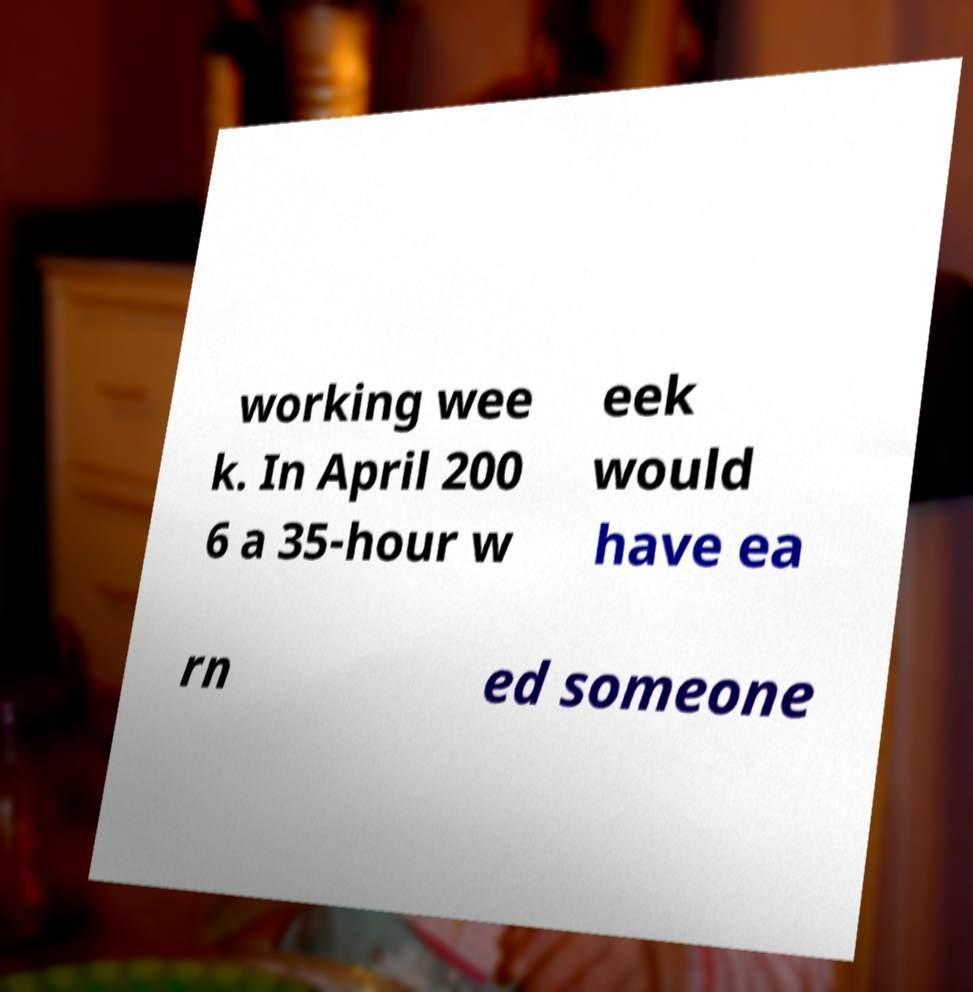Could you extract and type out the text from this image? working wee k. In April 200 6 a 35-hour w eek would have ea rn ed someone 